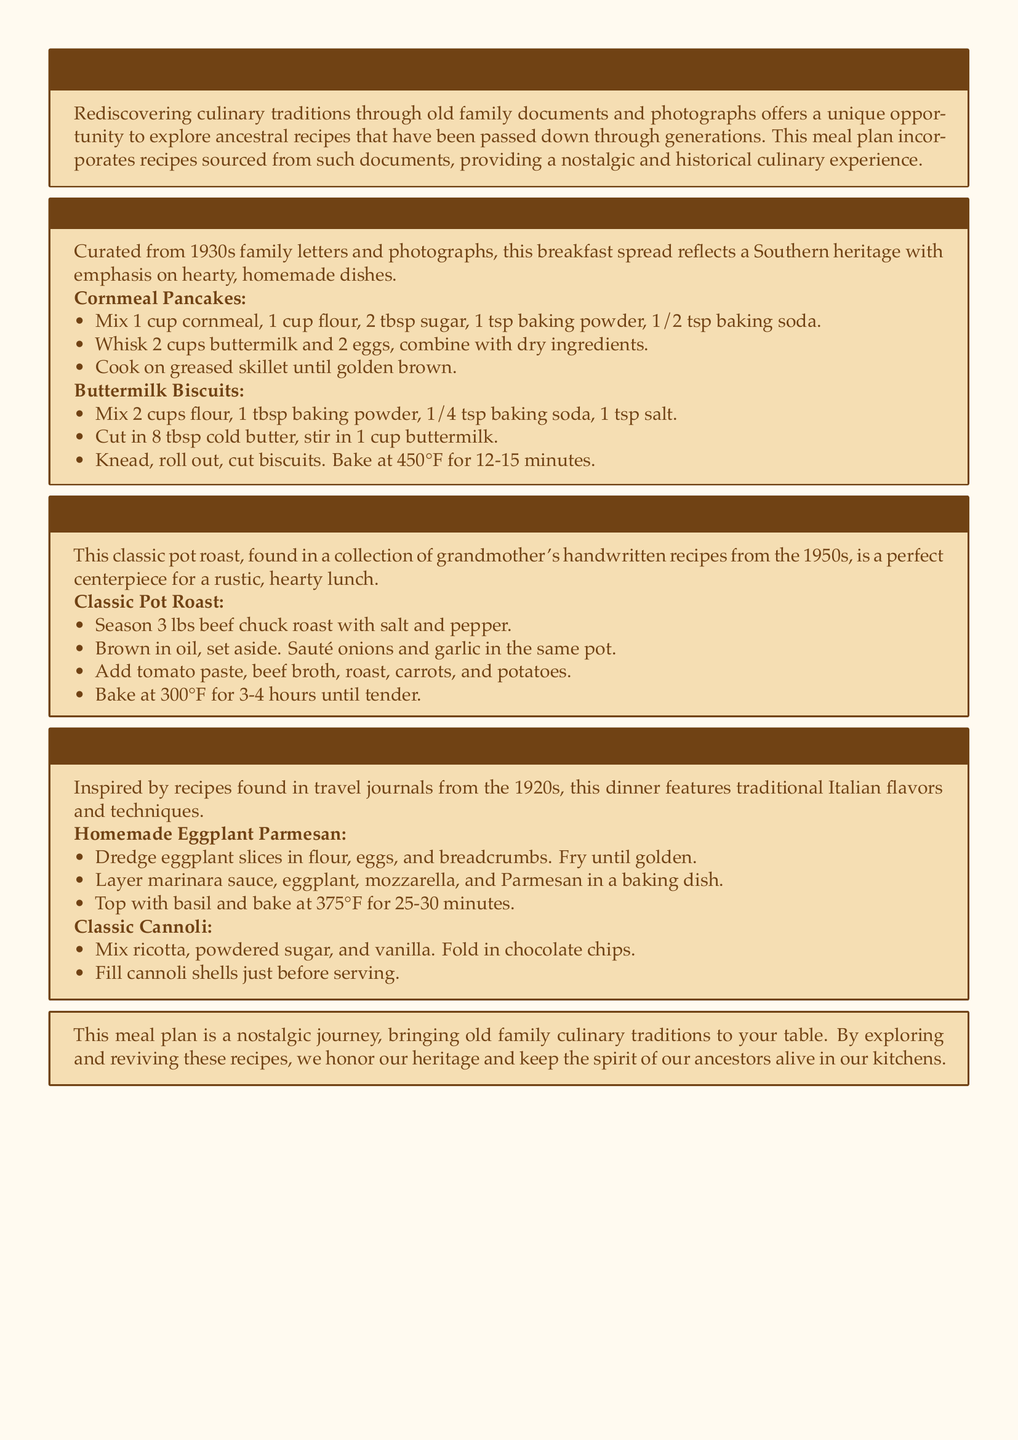What is the title of the meal plan? The title is prominently displayed at the top of the document, which is "Rediscovered Culinary Traditions."
Answer: Rediscovered Culinary Traditions What type of cuisine does the "Southern Breakfast Feast" represent? The "Southern Breakfast Feast" reflects dishes characteristic of Southern cuisine, as specified in the description.
Answer: Southern How many pounds of beef chuck roast are used in the pot roast recipe? The pot roast recipe states that it uses 3 lbs of beef chuck roast.
Answer: 3 lbs At what temperature should the classic buttermilk biscuits be baked? The temperature for baking buttermilk biscuits is mentioned in the biscuit recipe.
Answer: 450°F What is the main ingredient in the homemade eggplant parmesan besides eggplant? The description refers to marinara sauce as a central component of the eggplant parmesan.
Answer: Marinara sauce What decade do the family letters and photographs originate from for the breakfast spread? The breakfast spread is curated from 1930s family letters and photographs.
Answer: 1930s What is the cooking time for the classic pot roast? The cooking time for the pot roast is indicated as 3-4 hours until tender.
Answer: 3-4 hours What flavor profiles are incorporated in the Italian family dinner? The Italian family dinner features traditional Italian flavors, as specified in the description.
Answer: Traditional Italian flavors 